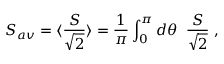Convert formula to latex. <formula><loc_0><loc_0><loc_500><loc_500>S _ { a v } = \langle \frac { S } { \sqrt { 2 } } \rangle = \frac { 1 } { \pi } \int _ { 0 } ^ { \pi } d \theta \, \frac { S } { \sqrt { 2 } } \, ,</formula> 